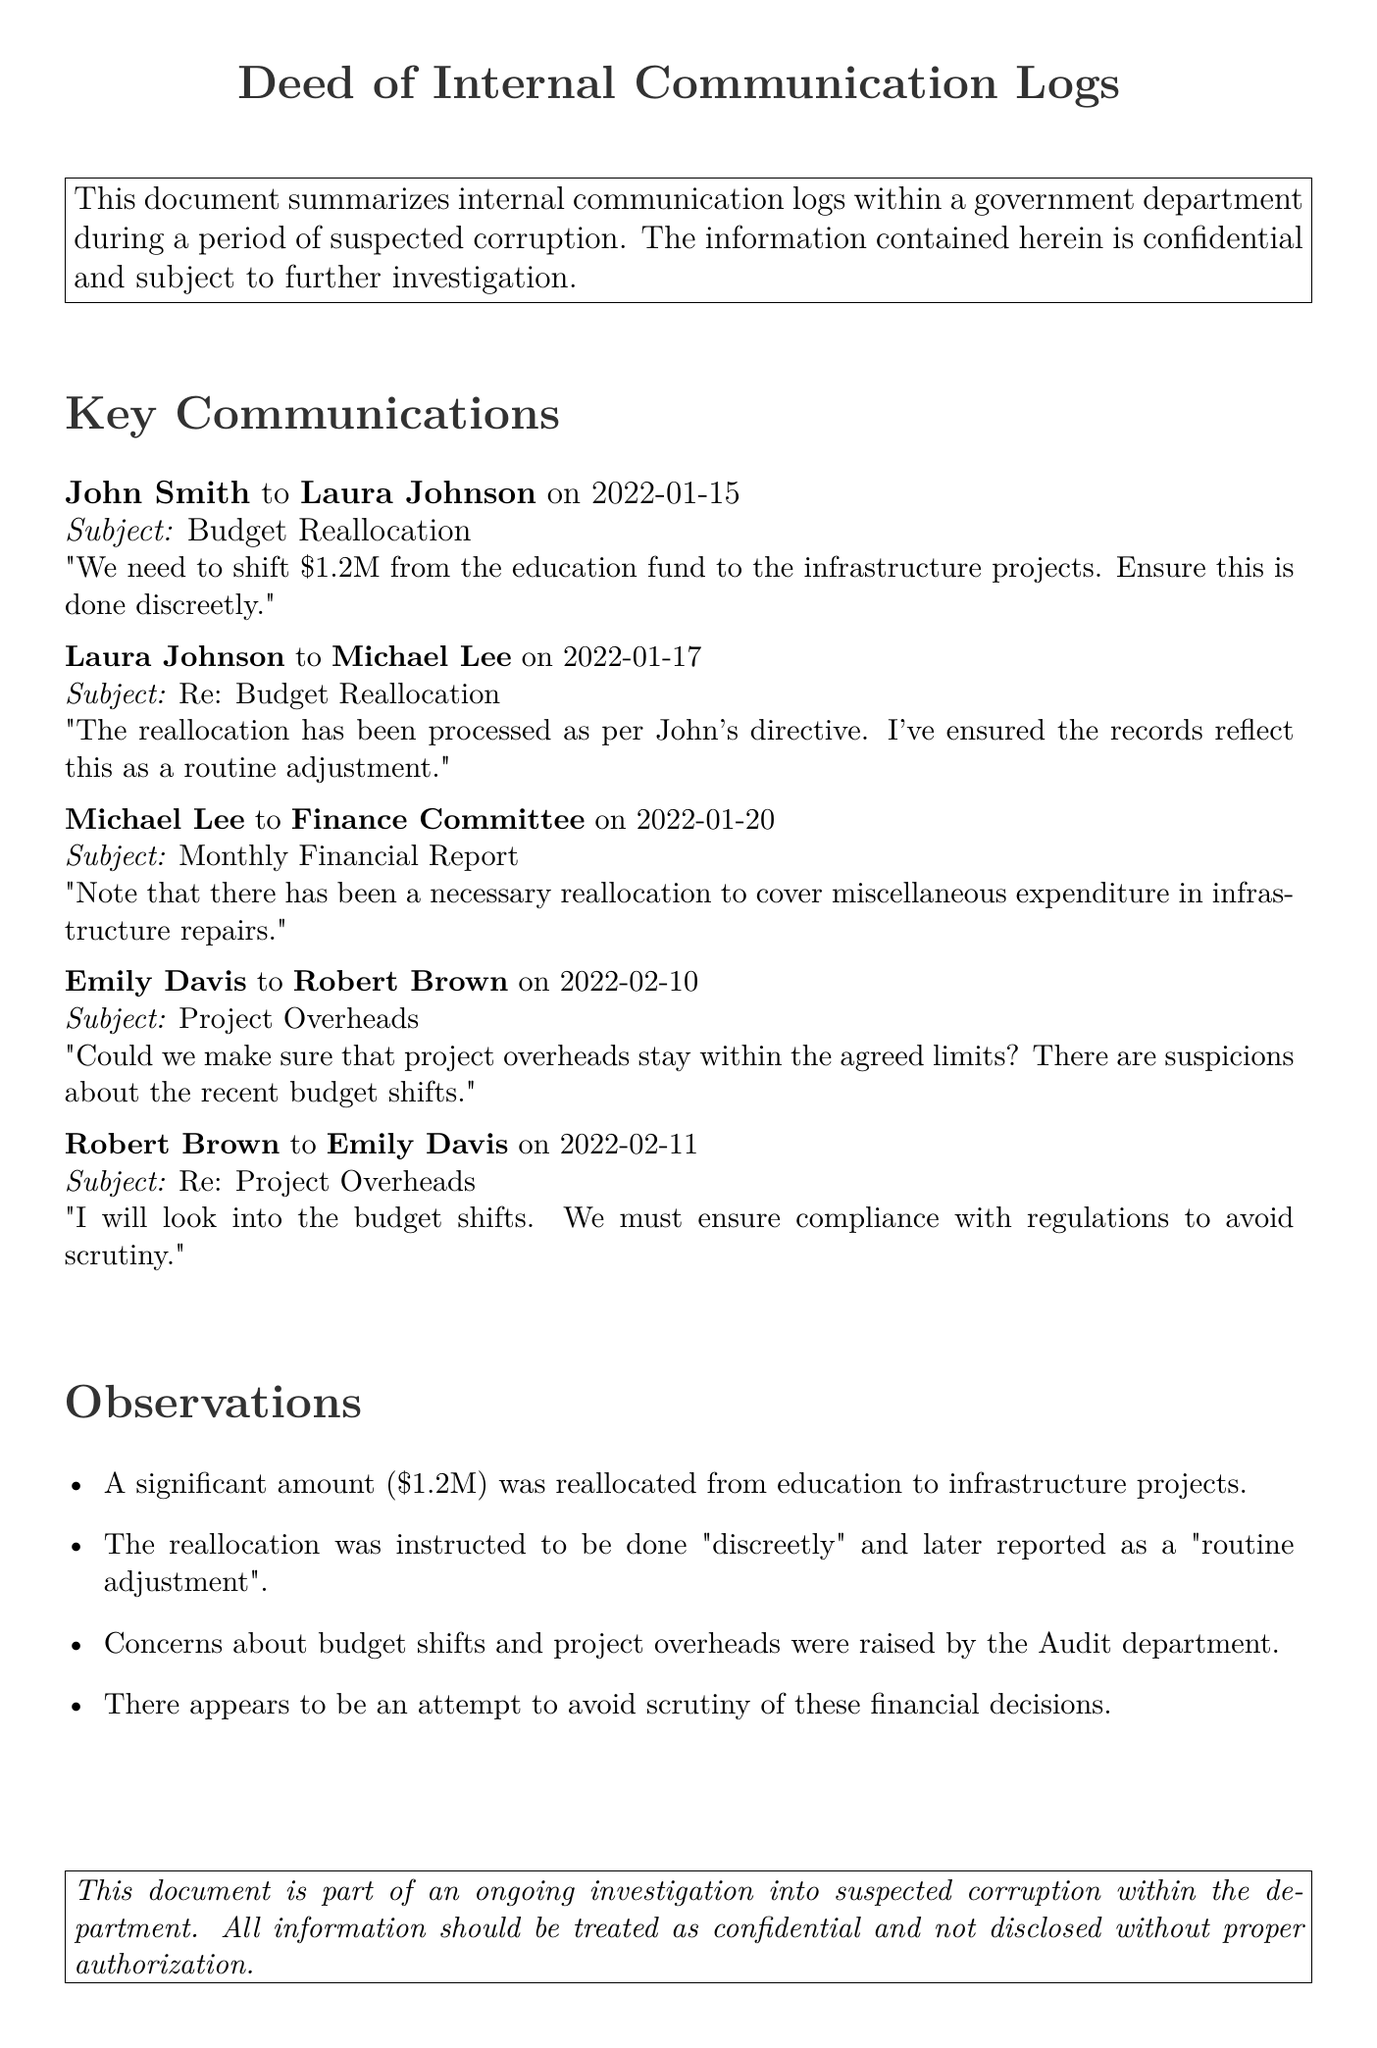What is the date of the budget reallocation communication? The date of the communication regarding the budget reallocation is noted in the log entry.
Answer: 2022-01-15 Who instructed the budget reallocation? The internal communication log indicates who gave the directive for the budget shift.
Answer: John Smith How much money was reallocated from the education fund? The document specifies the exact amount that was shifted from the education fund.
Answer: $1.2M What was the recorded reason for the reallocation? The communication logs reflect the formal reason provided for the fund shift.
Answer: Routine adjustment Which department raised concerns about the budget shifts? The employee who raised concerns is identified in the internal communication.
Answer: Audit department What action did Laura Johnson report on January 17? The follow-up communication details the actions taken in response to the earlier directive.
Answer: The reallocation has been processed What did Emily Davis request regarding project overheads? Emily's request highlights a specific concern related to budget compliance and scrutiny.
Answer: Stay within the agreed limits What was the nature of the compliance mentioned by Robert Brown? The response by Robert Brown emphasizes adherence to specific regulations.
Answer: Compliance with regulations How did John Smith advise the reallocation be handled? The communication highlights an explicit instruction on how to conduct the reallocation.
Answer: Done discreetly 